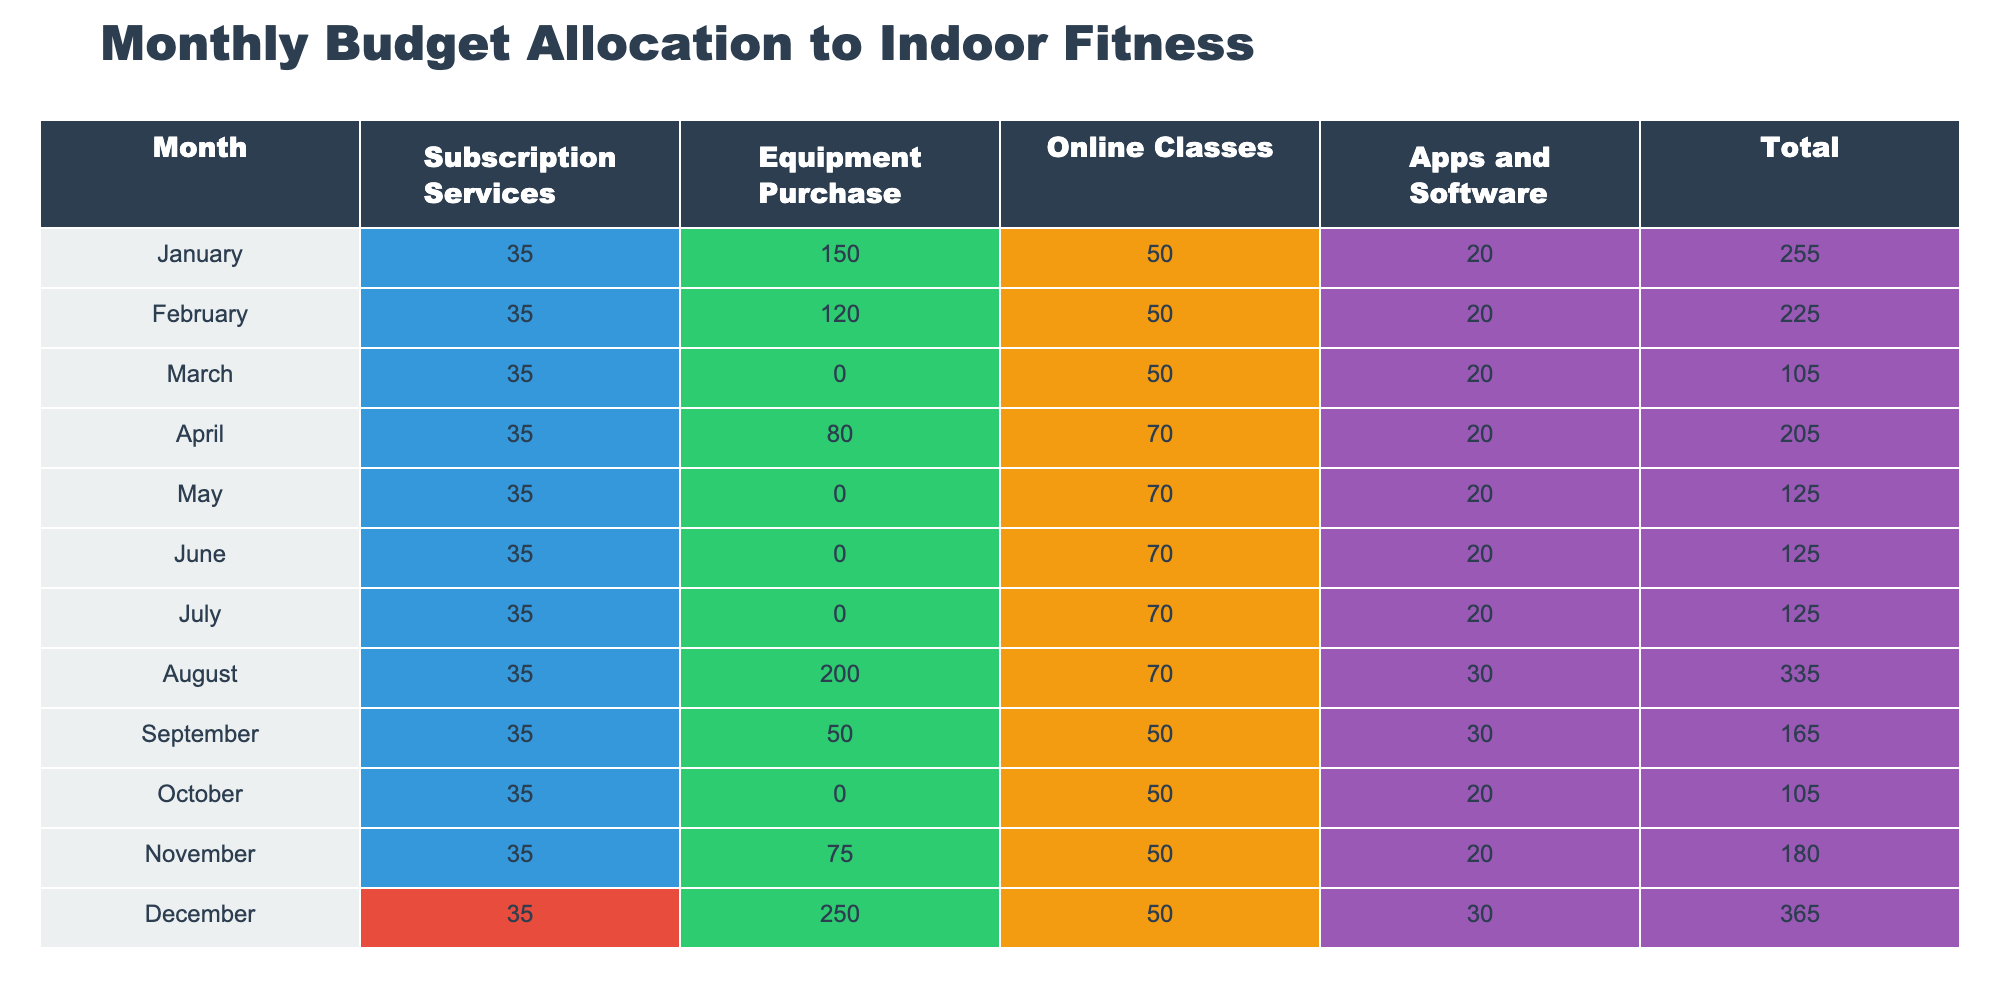What was the highest monthly expenditure on equipment purchase? The highest value in the "Equipment Purchase" column is 250, which occurred in December.
Answer: 250 In which month was the total expenditure the lowest? The lowest value in the "Total" column is 105, which occurred in both March and October.
Answer: March and October What is the average spending on subscription services for the year? The total spending on subscription services is (35 * 12) = 420, and there are 12 months, so the average is 420 / 12 = 35.
Answer: 35 Did the expenditure on online classes increase from January to December? The expenditure on online classes was 50 in January and remained at 50 from January to October, then increased to 70 in April, 70 in May, 70 in June, 70 in July, and returned to 50 in November. Hence, it did not continuously increase.
Answer: No What was the total expenditure on equipment purchases for the first half of the year? The total for January (150), February (120), March (0), April (80), May (0), and June (0) is 150 + 120 + 0 + 80 + 0 + 0 = 350.
Answer: 350 What is the difference in total expenditure between the month with the highest total and the month with the lowest total? The highest total expenditure is 365 in December, and the lowest is 105 in March (or October), so the difference is 365 - 105 = 260.
Answer: 260 Which month had the highest total expenditure on online classes? The maximum for online classes is 70 in both April, May, June, and July while it was 50 in January, February, October, and November. Thus, multiple months are tied for the highest.
Answer: April, May, June, July In what month did the total spending exceed 300? The total spending exceeded 300 only in August (335) and December (365).
Answer: August and December How much was spent on apps and software in July? In July, the expenditure on apps and software is 20.
Answer: 20 